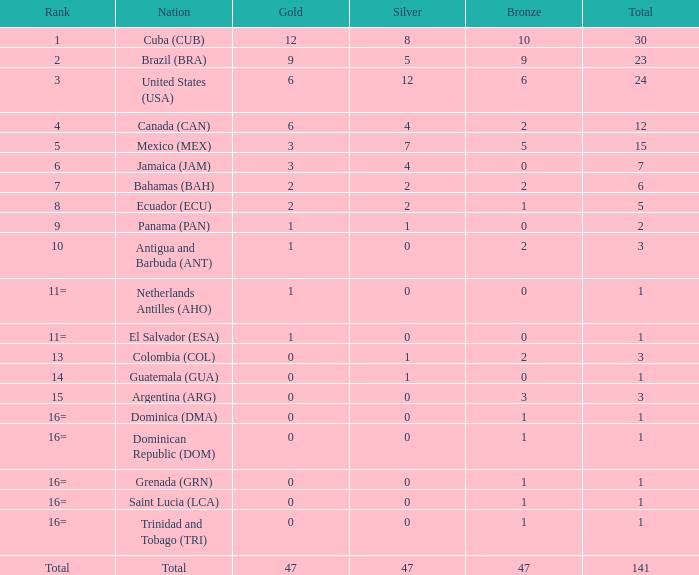What is the total gold with a total less than 1? None. 